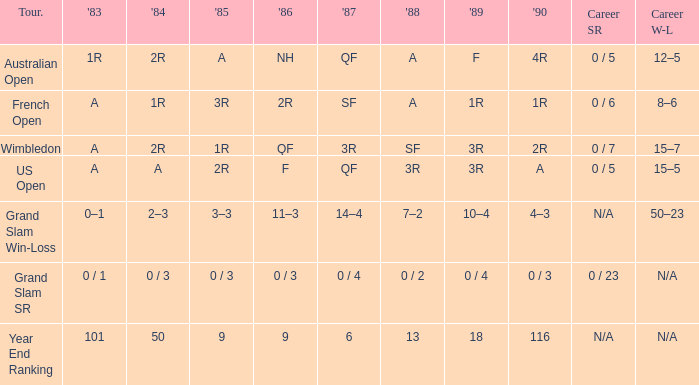With a 1986 of NH and a career SR of 0 / 5 what is the results in 1985? A. 